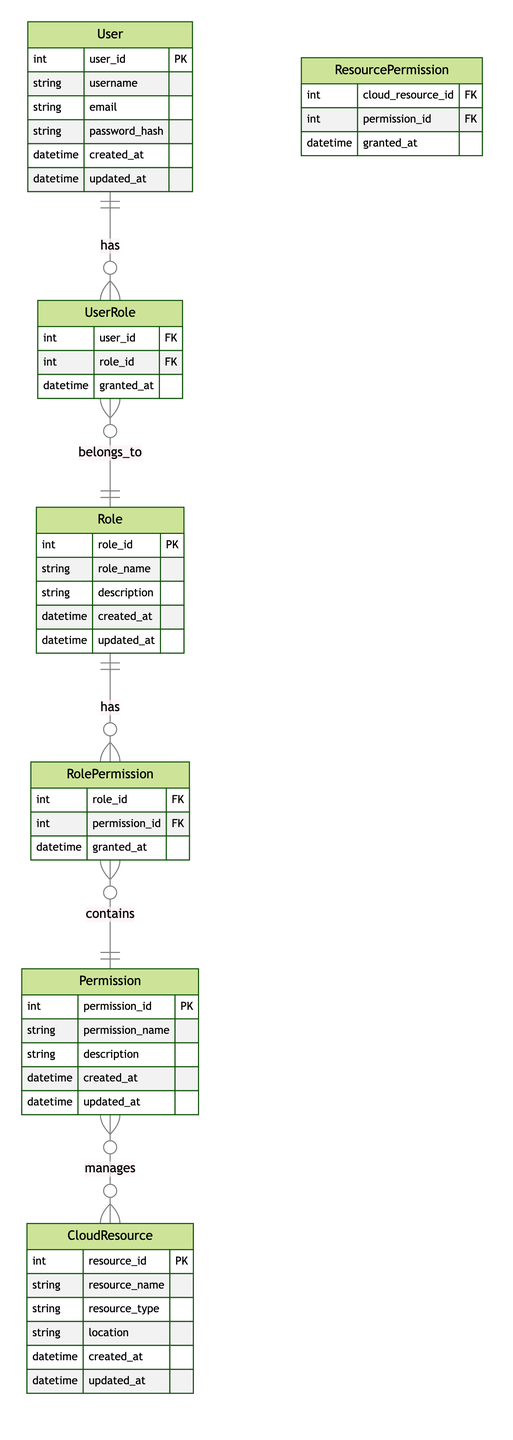What is the primary key of the User entity? The primary key of the User entity is user_id, which uniquely identifies each user in the system.
Answer: user_id How many attributes does the Role entity have? The Role entity has five attributes: role_id, role_name, description, created_at, and updated_at, making a total of five.
Answer: five What type of relationship exists between User and UserRole? The relationship between User and UserRole is a one-to-many relationship, meaning one user can have multiple roles.
Answer: one-to-many Which entity is associated with managing Cloud Resources? The entity associated with managing Cloud Resources is Permission. This relationship indicates that permissions govern access to various cloud resources.
Answer: Permission How many foreign keys are in the UserRole entity? The UserRole entity has two foreign keys: user_id and role_id, linking it to the User and Role entities respectively.
Answer: two What can be inferred about the Role and RolePermission relationship? The Role and RolePermission relationship is a one-to-many relationship, indicating that one role can have multiple assigned permissions.
Answer: one-to-many Which table directly connects Permissions to Cloud Resources? The table that directly connects Permissions to Cloud Resources is ResourcePermission. This helps track which permissions are granted for which cloud resources.
Answer: ResourcePermission What is the function of the granted_at attribute in the UserRole entity? The granted_at attribute in the UserRole entity indicates the timestamp when a user was granted a particular role, providing historical context.
Answer: timestamp How many relationships involve the Permission entity? The Permission entity is involved in three relationships: with RolePermission, ResourcePermission, and manages CloudResource, totaling three relationships.
Answer: three 